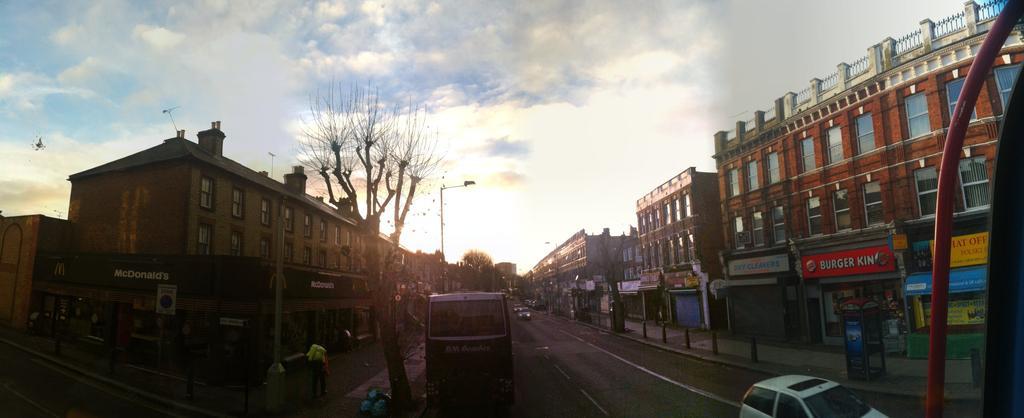Describe this image in one or two sentences. In this picture there are buildings on the right and left side of the image, there are which includes Mcdonalds, burger king and other stalls, there are buses and cars on the road at the bottom side of the image, there are poles in the image and there is a tree in the center of the image and there are trees in the background area of the image. 